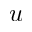<formula> <loc_0><loc_0><loc_500><loc_500>u</formula> 